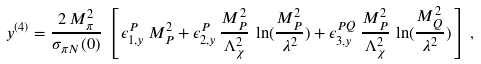<formula> <loc_0><loc_0><loc_500><loc_500>y ^ { ( 4 ) } = \frac { 2 \, M _ { \pi } ^ { 2 } } { \sigma _ { \pi N } ( 0 ) } \, \left [ \, \epsilon _ { 1 , y } ^ { P } \, M _ { P } ^ { 2 } + \epsilon _ { 2 , y } ^ { P } \, \frac { M _ { P } ^ { 2 } } { \Lambda _ { \chi } ^ { 2 } } \, \ln ( \frac { M _ { P } ^ { 2 } } { \lambda ^ { 2 } } ) + \epsilon _ { 3 , y } ^ { P Q } \, \frac { M _ { P } ^ { 2 } } { \Lambda _ { \chi } ^ { 2 } } \, \ln ( \frac { M _ { Q } ^ { 2 } } { \lambda ^ { 2 } } ) \, \right ] \, ,</formula> 